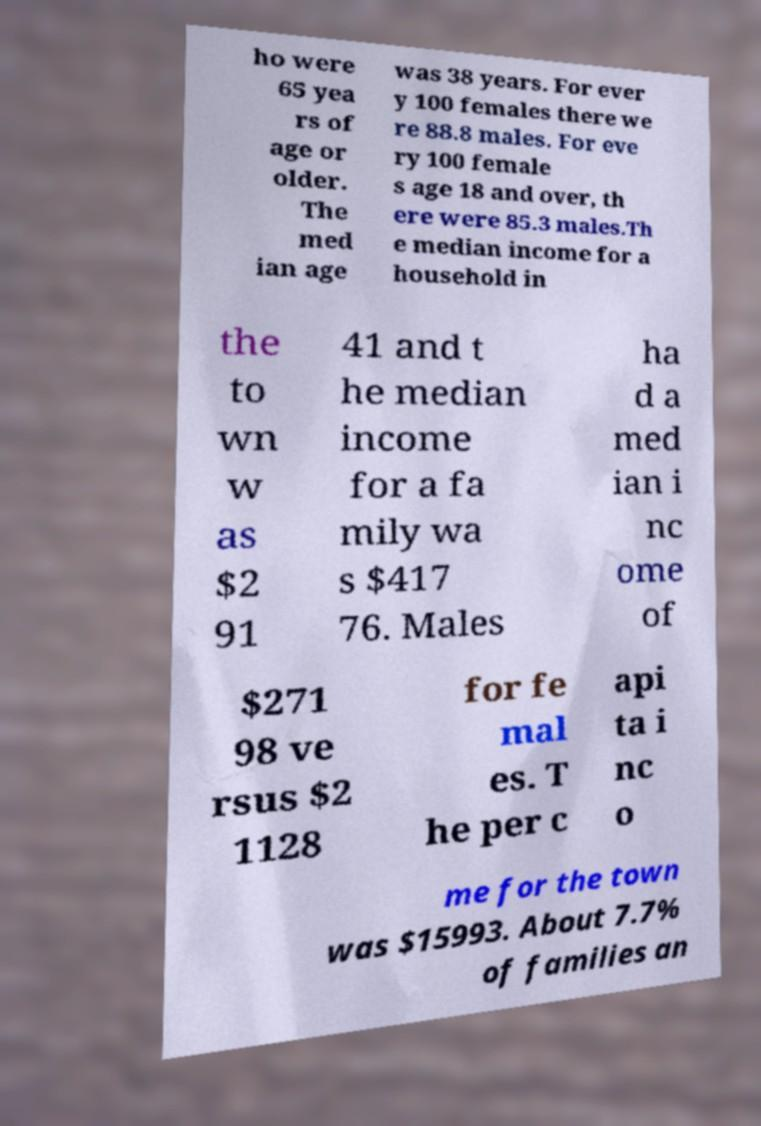Could you assist in decoding the text presented in this image and type it out clearly? ho were 65 yea rs of age or older. The med ian age was 38 years. For ever y 100 females there we re 88.8 males. For eve ry 100 female s age 18 and over, th ere were 85.3 males.Th e median income for a household in the to wn w as $2 91 41 and t he median income for a fa mily wa s $417 76. Males ha d a med ian i nc ome of $271 98 ve rsus $2 1128 for fe mal es. T he per c api ta i nc o me for the town was $15993. About 7.7% of families an 